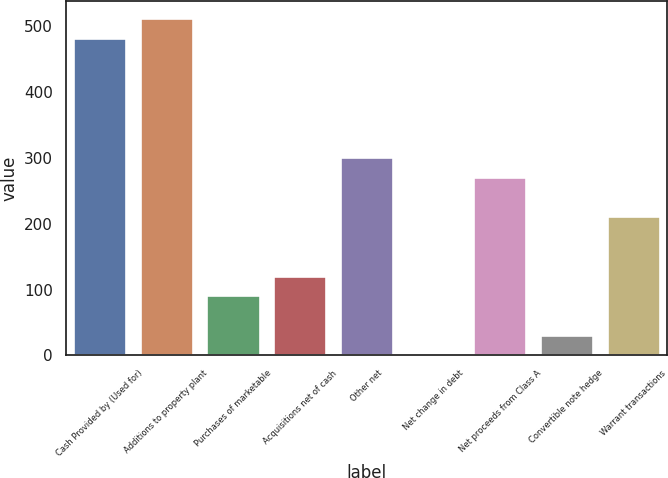Convert chart to OTSL. <chart><loc_0><loc_0><loc_500><loc_500><bar_chart><fcel>Cash Provided by (Used for)<fcel>Additions to property plant<fcel>Purchases of marketable<fcel>Acquisitions net of cash<fcel>Other net<fcel>Net change in debt<fcel>Net proceeds from Class A<fcel>Convertible note hedge<fcel>Warrant transactions<nl><fcel>482.75<fcel>512.88<fcel>91.06<fcel>121.19<fcel>301.97<fcel>0.67<fcel>271.84<fcel>30.8<fcel>211.58<nl></chart> 